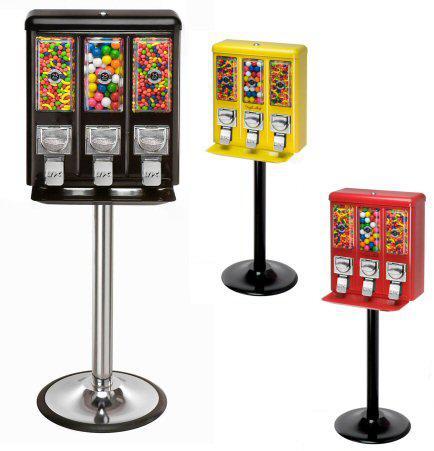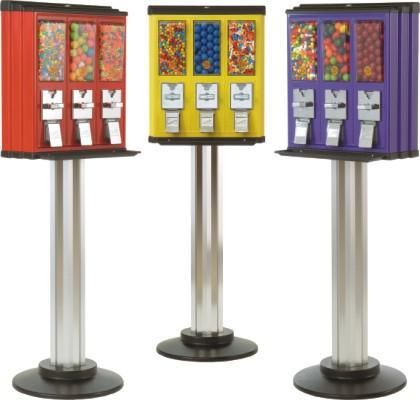The first image is the image on the left, the second image is the image on the right. Given the left and right images, does the statement "An image shows just one vending machine, which has a trio of dispensers combined into one rectangular box shape." hold true? Answer yes or no. No. 